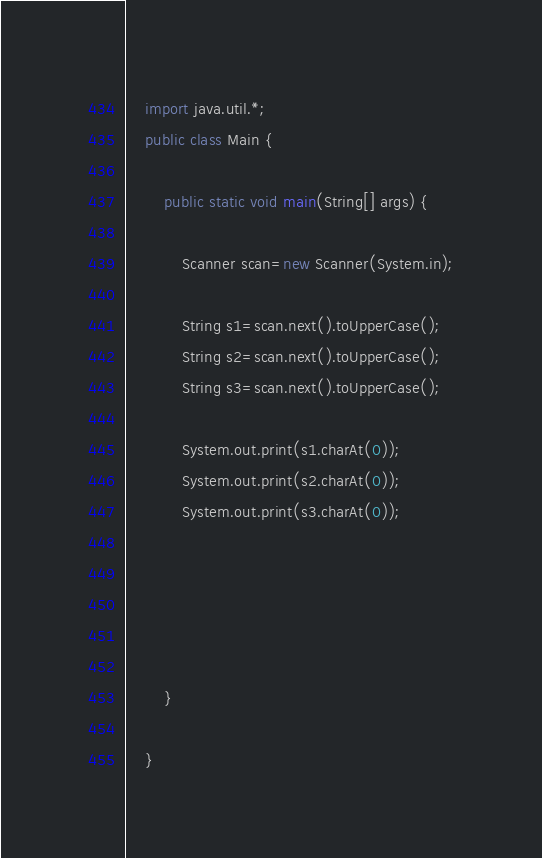Convert code to text. <code><loc_0><loc_0><loc_500><loc_500><_Java_>    import java.util.*;
    public class Main {
     
    	public static void main(String[] args) {
    			
    		Scanner scan=new Scanner(System.in);
    		
    		String s1=scan.next().toUpperCase();
    		String s2=scan.next().toUpperCase();
    		String s3=scan.next().toUpperCase();
    		
    		System.out.print(s1.charAt(0));
    		System.out.print(s2.charAt(0));
    		System.out.print(s3.charAt(0));

    		
    	
  
    				
    	}
     
    }</code> 